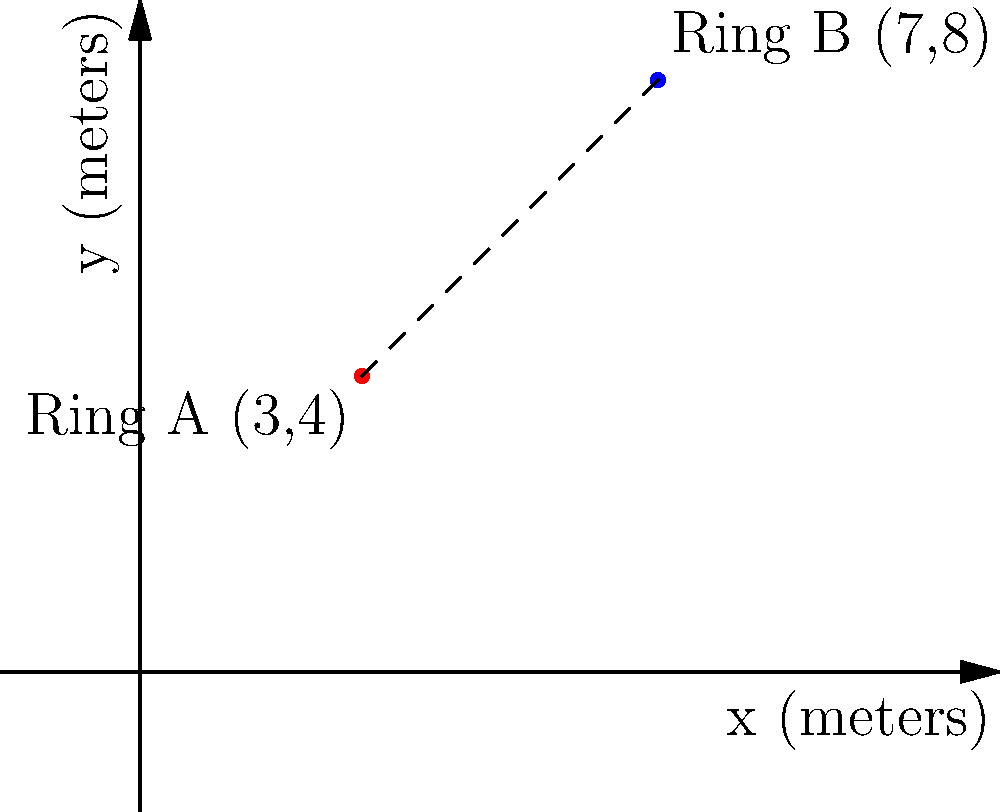As the organizer of a major boxing event in a large arena, you need to calculate the distance between two boxing rings. Ring A is located at coordinates (3,4) and Ring B is at (7,8) on the arena floor plan, where each unit represents 1 meter. What is the shortest distance between the centers of these two rings? To find the shortest distance between two points in a Cartesian coordinate system, we can use the distance formula, which is derived from the Pythagorean theorem:

$$d = \sqrt{(x_2 - x_1)^2 + (y_2 - y_1)^2}$$

Where $(x_1, y_1)$ are the coordinates of the first point and $(x_2, y_2)$ are the coordinates of the second point.

Let's plug in our values:
Ring A: $(x_1, y_1) = (3, 4)$
Ring B: $(x_2, y_2) = (7, 8)$

Now, let's calculate:

1) First, find the differences:
   $x_2 - x_1 = 7 - 3 = 4$
   $y_2 - y_1 = 8 - 4 = 4$

2) Square these differences:
   $(x_2 - x_1)^2 = 4^2 = 16$
   $(y_2 - y_1)^2 = 4^2 = 16$

3) Sum the squared differences:
   $16 + 16 = 32$

4) Take the square root of the sum:
   $d = \sqrt{32}$

5) Simplify:
   $d = \sqrt{16 \cdot 2} = 4\sqrt{2}$

Therefore, the shortest distance between the centers of the two boxing rings is $4\sqrt{2}$ meters.
Answer: $4\sqrt{2}$ meters 